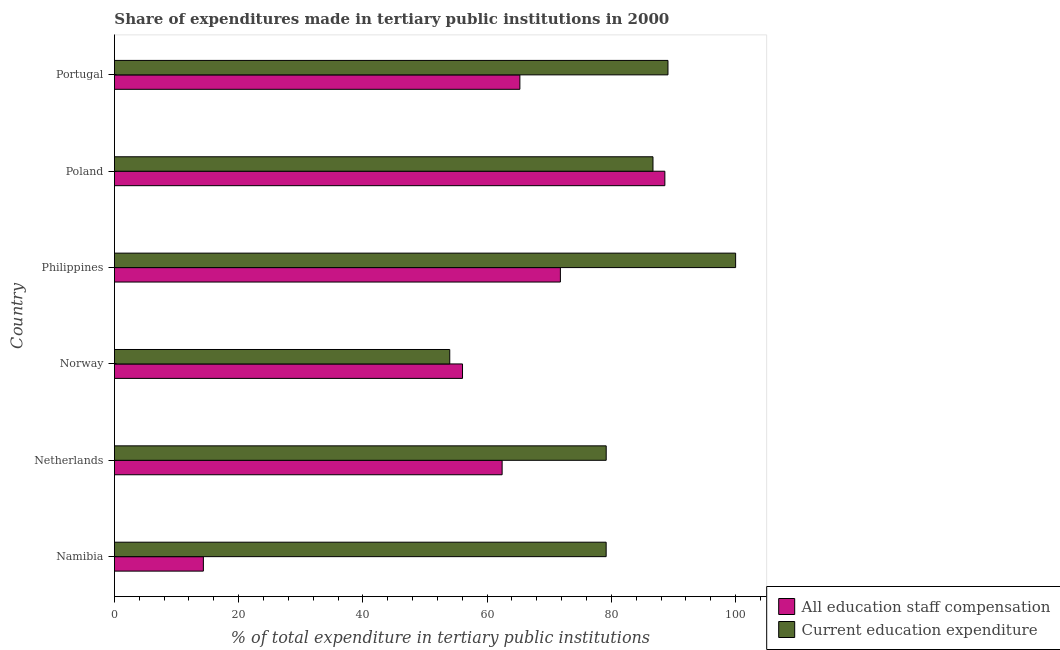How many different coloured bars are there?
Your response must be concise. 2. Are the number of bars on each tick of the Y-axis equal?
Keep it short and to the point. Yes. How many bars are there on the 2nd tick from the bottom?
Make the answer very short. 2. What is the expenditure in education in Portugal?
Your answer should be very brief. 89.11. Across all countries, what is the maximum expenditure in staff compensation?
Ensure brevity in your answer.  88.61. Across all countries, what is the minimum expenditure in staff compensation?
Provide a short and direct response. 14.32. In which country was the expenditure in education minimum?
Offer a very short reply. Norway. What is the total expenditure in staff compensation in the graph?
Your answer should be compact. 358.44. What is the difference between the expenditure in education in Norway and that in Poland?
Offer a very short reply. -32.72. What is the difference between the expenditure in staff compensation in Philippines and the expenditure in education in Norway?
Provide a short and direct response. 17.81. What is the average expenditure in education per country?
Your response must be concise. 81.35. What is the difference between the expenditure in staff compensation and expenditure in education in Norway?
Keep it short and to the point. 2.06. In how many countries, is the expenditure in staff compensation greater than 8 %?
Give a very brief answer. 6. What is the ratio of the expenditure in education in Netherlands to that in Portugal?
Offer a terse response. 0.89. Is the expenditure in education in Norway less than that in Poland?
Make the answer very short. Yes. What is the difference between the highest and the second highest expenditure in staff compensation?
Make the answer very short. 16.82. What is the difference between the highest and the lowest expenditure in staff compensation?
Provide a short and direct response. 74.29. In how many countries, is the expenditure in staff compensation greater than the average expenditure in staff compensation taken over all countries?
Ensure brevity in your answer.  4. What does the 1st bar from the top in Norway represents?
Ensure brevity in your answer.  Current education expenditure. What does the 1st bar from the bottom in Poland represents?
Your answer should be compact. All education staff compensation. How many bars are there?
Your answer should be compact. 12. What is the difference between two consecutive major ticks on the X-axis?
Your answer should be compact. 20. Does the graph contain grids?
Your response must be concise. No. How many legend labels are there?
Keep it short and to the point. 2. How are the legend labels stacked?
Offer a very short reply. Vertical. What is the title of the graph?
Ensure brevity in your answer.  Share of expenditures made in tertiary public institutions in 2000. What is the label or title of the X-axis?
Your response must be concise. % of total expenditure in tertiary public institutions. What is the label or title of the Y-axis?
Provide a succinct answer. Country. What is the % of total expenditure in tertiary public institutions of All education staff compensation in Namibia?
Provide a short and direct response. 14.32. What is the % of total expenditure in tertiary public institutions of Current education expenditure in Namibia?
Provide a short and direct response. 79.16. What is the % of total expenditure in tertiary public institutions in All education staff compensation in Netherlands?
Provide a short and direct response. 62.41. What is the % of total expenditure in tertiary public institutions of Current education expenditure in Netherlands?
Offer a very short reply. 79.17. What is the % of total expenditure in tertiary public institutions in All education staff compensation in Norway?
Offer a very short reply. 56.04. What is the % of total expenditure in tertiary public institutions of Current education expenditure in Norway?
Give a very brief answer. 53.98. What is the % of total expenditure in tertiary public institutions in All education staff compensation in Philippines?
Keep it short and to the point. 71.79. What is the % of total expenditure in tertiary public institutions of Current education expenditure in Philippines?
Provide a short and direct response. 100. What is the % of total expenditure in tertiary public institutions in All education staff compensation in Poland?
Ensure brevity in your answer.  88.61. What is the % of total expenditure in tertiary public institutions in Current education expenditure in Poland?
Provide a succinct answer. 86.7. What is the % of total expenditure in tertiary public institutions in All education staff compensation in Portugal?
Keep it short and to the point. 65.27. What is the % of total expenditure in tertiary public institutions in Current education expenditure in Portugal?
Make the answer very short. 89.11. Across all countries, what is the maximum % of total expenditure in tertiary public institutions in All education staff compensation?
Ensure brevity in your answer.  88.61. Across all countries, what is the maximum % of total expenditure in tertiary public institutions in Current education expenditure?
Make the answer very short. 100. Across all countries, what is the minimum % of total expenditure in tertiary public institutions of All education staff compensation?
Offer a terse response. 14.32. Across all countries, what is the minimum % of total expenditure in tertiary public institutions in Current education expenditure?
Provide a succinct answer. 53.98. What is the total % of total expenditure in tertiary public institutions in All education staff compensation in the graph?
Your answer should be compact. 358.44. What is the total % of total expenditure in tertiary public institutions in Current education expenditure in the graph?
Make the answer very short. 488.11. What is the difference between the % of total expenditure in tertiary public institutions in All education staff compensation in Namibia and that in Netherlands?
Your answer should be very brief. -48.09. What is the difference between the % of total expenditure in tertiary public institutions in Current education expenditure in Namibia and that in Netherlands?
Your response must be concise. -0.01. What is the difference between the % of total expenditure in tertiary public institutions of All education staff compensation in Namibia and that in Norway?
Ensure brevity in your answer.  -41.72. What is the difference between the % of total expenditure in tertiary public institutions of Current education expenditure in Namibia and that in Norway?
Keep it short and to the point. 25.18. What is the difference between the % of total expenditure in tertiary public institutions of All education staff compensation in Namibia and that in Philippines?
Provide a short and direct response. -57.47. What is the difference between the % of total expenditure in tertiary public institutions of Current education expenditure in Namibia and that in Philippines?
Provide a short and direct response. -20.84. What is the difference between the % of total expenditure in tertiary public institutions of All education staff compensation in Namibia and that in Poland?
Your answer should be very brief. -74.29. What is the difference between the % of total expenditure in tertiary public institutions of Current education expenditure in Namibia and that in Poland?
Keep it short and to the point. -7.54. What is the difference between the % of total expenditure in tertiary public institutions in All education staff compensation in Namibia and that in Portugal?
Provide a succinct answer. -50.95. What is the difference between the % of total expenditure in tertiary public institutions in Current education expenditure in Namibia and that in Portugal?
Your answer should be compact. -9.95. What is the difference between the % of total expenditure in tertiary public institutions in All education staff compensation in Netherlands and that in Norway?
Offer a terse response. 6.38. What is the difference between the % of total expenditure in tertiary public institutions of Current education expenditure in Netherlands and that in Norway?
Give a very brief answer. 25.19. What is the difference between the % of total expenditure in tertiary public institutions of All education staff compensation in Netherlands and that in Philippines?
Ensure brevity in your answer.  -9.38. What is the difference between the % of total expenditure in tertiary public institutions of Current education expenditure in Netherlands and that in Philippines?
Make the answer very short. -20.83. What is the difference between the % of total expenditure in tertiary public institutions of All education staff compensation in Netherlands and that in Poland?
Provide a short and direct response. -26.2. What is the difference between the % of total expenditure in tertiary public institutions in Current education expenditure in Netherlands and that in Poland?
Give a very brief answer. -7.53. What is the difference between the % of total expenditure in tertiary public institutions of All education staff compensation in Netherlands and that in Portugal?
Give a very brief answer. -2.86. What is the difference between the % of total expenditure in tertiary public institutions in Current education expenditure in Netherlands and that in Portugal?
Your answer should be very brief. -9.94. What is the difference between the % of total expenditure in tertiary public institutions in All education staff compensation in Norway and that in Philippines?
Offer a very short reply. -15.76. What is the difference between the % of total expenditure in tertiary public institutions of Current education expenditure in Norway and that in Philippines?
Ensure brevity in your answer.  -46.02. What is the difference between the % of total expenditure in tertiary public institutions of All education staff compensation in Norway and that in Poland?
Your answer should be compact. -32.57. What is the difference between the % of total expenditure in tertiary public institutions in Current education expenditure in Norway and that in Poland?
Your answer should be compact. -32.72. What is the difference between the % of total expenditure in tertiary public institutions in All education staff compensation in Norway and that in Portugal?
Your answer should be very brief. -9.23. What is the difference between the % of total expenditure in tertiary public institutions of Current education expenditure in Norway and that in Portugal?
Keep it short and to the point. -35.13. What is the difference between the % of total expenditure in tertiary public institutions of All education staff compensation in Philippines and that in Poland?
Your answer should be compact. -16.82. What is the difference between the % of total expenditure in tertiary public institutions of Current education expenditure in Philippines and that in Poland?
Provide a succinct answer. 13.3. What is the difference between the % of total expenditure in tertiary public institutions in All education staff compensation in Philippines and that in Portugal?
Give a very brief answer. 6.52. What is the difference between the % of total expenditure in tertiary public institutions of Current education expenditure in Philippines and that in Portugal?
Provide a succinct answer. 10.89. What is the difference between the % of total expenditure in tertiary public institutions in All education staff compensation in Poland and that in Portugal?
Offer a terse response. 23.34. What is the difference between the % of total expenditure in tertiary public institutions of Current education expenditure in Poland and that in Portugal?
Provide a short and direct response. -2.41. What is the difference between the % of total expenditure in tertiary public institutions in All education staff compensation in Namibia and the % of total expenditure in tertiary public institutions in Current education expenditure in Netherlands?
Ensure brevity in your answer.  -64.85. What is the difference between the % of total expenditure in tertiary public institutions in All education staff compensation in Namibia and the % of total expenditure in tertiary public institutions in Current education expenditure in Norway?
Give a very brief answer. -39.66. What is the difference between the % of total expenditure in tertiary public institutions in All education staff compensation in Namibia and the % of total expenditure in tertiary public institutions in Current education expenditure in Philippines?
Offer a very short reply. -85.68. What is the difference between the % of total expenditure in tertiary public institutions in All education staff compensation in Namibia and the % of total expenditure in tertiary public institutions in Current education expenditure in Poland?
Offer a terse response. -72.38. What is the difference between the % of total expenditure in tertiary public institutions in All education staff compensation in Namibia and the % of total expenditure in tertiary public institutions in Current education expenditure in Portugal?
Ensure brevity in your answer.  -74.79. What is the difference between the % of total expenditure in tertiary public institutions in All education staff compensation in Netherlands and the % of total expenditure in tertiary public institutions in Current education expenditure in Norway?
Your answer should be compact. 8.43. What is the difference between the % of total expenditure in tertiary public institutions of All education staff compensation in Netherlands and the % of total expenditure in tertiary public institutions of Current education expenditure in Philippines?
Your response must be concise. -37.59. What is the difference between the % of total expenditure in tertiary public institutions in All education staff compensation in Netherlands and the % of total expenditure in tertiary public institutions in Current education expenditure in Poland?
Provide a succinct answer. -24.28. What is the difference between the % of total expenditure in tertiary public institutions in All education staff compensation in Netherlands and the % of total expenditure in tertiary public institutions in Current education expenditure in Portugal?
Ensure brevity in your answer.  -26.7. What is the difference between the % of total expenditure in tertiary public institutions in All education staff compensation in Norway and the % of total expenditure in tertiary public institutions in Current education expenditure in Philippines?
Provide a succinct answer. -43.96. What is the difference between the % of total expenditure in tertiary public institutions in All education staff compensation in Norway and the % of total expenditure in tertiary public institutions in Current education expenditure in Poland?
Make the answer very short. -30.66. What is the difference between the % of total expenditure in tertiary public institutions of All education staff compensation in Norway and the % of total expenditure in tertiary public institutions of Current education expenditure in Portugal?
Offer a terse response. -33.07. What is the difference between the % of total expenditure in tertiary public institutions of All education staff compensation in Philippines and the % of total expenditure in tertiary public institutions of Current education expenditure in Poland?
Offer a terse response. -14.91. What is the difference between the % of total expenditure in tertiary public institutions of All education staff compensation in Philippines and the % of total expenditure in tertiary public institutions of Current education expenditure in Portugal?
Provide a short and direct response. -17.32. What is the difference between the % of total expenditure in tertiary public institutions in All education staff compensation in Poland and the % of total expenditure in tertiary public institutions in Current education expenditure in Portugal?
Ensure brevity in your answer.  -0.5. What is the average % of total expenditure in tertiary public institutions in All education staff compensation per country?
Make the answer very short. 59.74. What is the average % of total expenditure in tertiary public institutions of Current education expenditure per country?
Keep it short and to the point. 81.35. What is the difference between the % of total expenditure in tertiary public institutions in All education staff compensation and % of total expenditure in tertiary public institutions in Current education expenditure in Namibia?
Offer a terse response. -64.84. What is the difference between the % of total expenditure in tertiary public institutions in All education staff compensation and % of total expenditure in tertiary public institutions in Current education expenditure in Netherlands?
Your answer should be compact. -16.75. What is the difference between the % of total expenditure in tertiary public institutions in All education staff compensation and % of total expenditure in tertiary public institutions in Current education expenditure in Norway?
Provide a succinct answer. 2.05. What is the difference between the % of total expenditure in tertiary public institutions of All education staff compensation and % of total expenditure in tertiary public institutions of Current education expenditure in Philippines?
Your answer should be very brief. -28.21. What is the difference between the % of total expenditure in tertiary public institutions of All education staff compensation and % of total expenditure in tertiary public institutions of Current education expenditure in Poland?
Make the answer very short. 1.91. What is the difference between the % of total expenditure in tertiary public institutions in All education staff compensation and % of total expenditure in tertiary public institutions in Current education expenditure in Portugal?
Provide a succinct answer. -23.84. What is the ratio of the % of total expenditure in tertiary public institutions in All education staff compensation in Namibia to that in Netherlands?
Make the answer very short. 0.23. What is the ratio of the % of total expenditure in tertiary public institutions in Current education expenditure in Namibia to that in Netherlands?
Make the answer very short. 1. What is the ratio of the % of total expenditure in tertiary public institutions of All education staff compensation in Namibia to that in Norway?
Ensure brevity in your answer.  0.26. What is the ratio of the % of total expenditure in tertiary public institutions of Current education expenditure in Namibia to that in Norway?
Provide a short and direct response. 1.47. What is the ratio of the % of total expenditure in tertiary public institutions in All education staff compensation in Namibia to that in Philippines?
Keep it short and to the point. 0.2. What is the ratio of the % of total expenditure in tertiary public institutions of Current education expenditure in Namibia to that in Philippines?
Give a very brief answer. 0.79. What is the ratio of the % of total expenditure in tertiary public institutions in All education staff compensation in Namibia to that in Poland?
Your response must be concise. 0.16. What is the ratio of the % of total expenditure in tertiary public institutions of All education staff compensation in Namibia to that in Portugal?
Make the answer very short. 0.22. What is the ratio of the % of total expenditure in tertiary public institutions in Current education expenditure in Namibia to that in Portugal?
Your answer should be very brief. 0.89. What is the ratio of the % of total expenditure in tertiary public institutions of All education staff compensation in Netherlands to that in Norway?
Give a very brief answer. 1.11. What is the ratio of the % of total expenditure in tertiary public institutions in Current education expenditure in Netherlands to that in Norway?
Give a very brief answer. 1.47. What is the ratio of the % of total expenditure in tertiary public institutions in All education staff compensation in Netherlands to that in Philippines?
Your response must be concise. 0.87. What is the ratio of the % of total expenditure in tertiary public institutions in Current education expenditure in Netherlands to that in Philippines?
Your answer should be very brief. 0.79. What is the ratio of the % of total expenditure in tertiary public institutions of All education staff compensation in Netherlands to that in Poland?
Give a very brief answer. 0.7. What is the ratio of the % of total expenditure in tertiary public institutions of Current education expenditure in Netherlands to that in Poland?
Offer a very short reply. 0.91. What is the ratio of the % of total expenditure in tertiary public institutions in All education staff compensation in Netherlands to that in Portugal?
Provide a succinct answer. 0.96. What is the ratio of the % of total expenditure in tertiary public institutions of Current education expenditure in Netherlands to that in Portugal?
Ensure brevity in your answer.  0.89. What is the ratio of the % of total expenditure in tertiary public institutions in All education staff compensation in Norway to that in Philippines?
Keep it short and to the point. 0.78. What is the ratio of the % of total expenditure in tertiary public institutions of Current education expenditure in Norway to that in Philippines?
Your answer should be compact. 0.54. What is the ratio of the % of total expenditure in tertiary public institutions in All education staff compensation in Norway to that in Poland?
Give a very brief answer. 0.63. What is the ratio of the % of total expenditure in tertiary public institutions in Current education expenditure in Norway to that in Poland?
Ensure brevity in your answer.  0.62. What is the ratio of the % of total expenditure in tertiary public institutions of All education staff compensation in Norway to that in Portugal?
Give a very brief answer. 0.86. What is the ratio of the % of total expenditure in tertiary public institutions of Current education expenditure in Norway to that in Portugal?
Provide a short and direct response. 0.61. What is the ratio of the % of total expenditure in tertiary public institutions of All education staff compensation in Philippines to that in Poland?
Provide a short and direct response. 0.81. What is the ratio of the % of total expenditure in tertiary public institutions of Current education expenditure in Philippines to that in Poland?
Your answer should be very brief. 1.15. What is the ratio of the % of total expenditure in tertiary public institutions in All education staff compensation in Philippines to that in Portugal?
Keep it short and to the point. 1.1. What is the ratio of the % of total expenditure in tertiary public institutions in Current education expenditure in Philippines to that in Portugal?
Your answer should be very brief. 1.12. What is the ratio of the % of total expenditure in tertiary public institutions of All education staff compensation in Poland to that in Portugal?
Offer a very short reply. 1.36. What is the ratio of the % of total expenditure in tertiary public institutions of Current education expenditure in Poland to that in Portugal?
Your response must be concise. 0.97. What is the difference between the highest and the second highest % of total expenditure in tertiary public institutions of All education staff compensation?
Provide a succinct answer. 16.82. What is the difference between the highest and the second highest % of total expenditure in tertiary public institutions in Current education expenditure?
Offer a very short reply. 10.89. What is the difference between the highest and the lowest % of total expenditure in tertiary public institutions of All education staff compensation?
Your answer should be very brief. 74.29. What is the difference between the highest and the lowest % of total expenditure in tertiary public institutions of Current education expenditure?
Offer a very short reply. 46.02. 